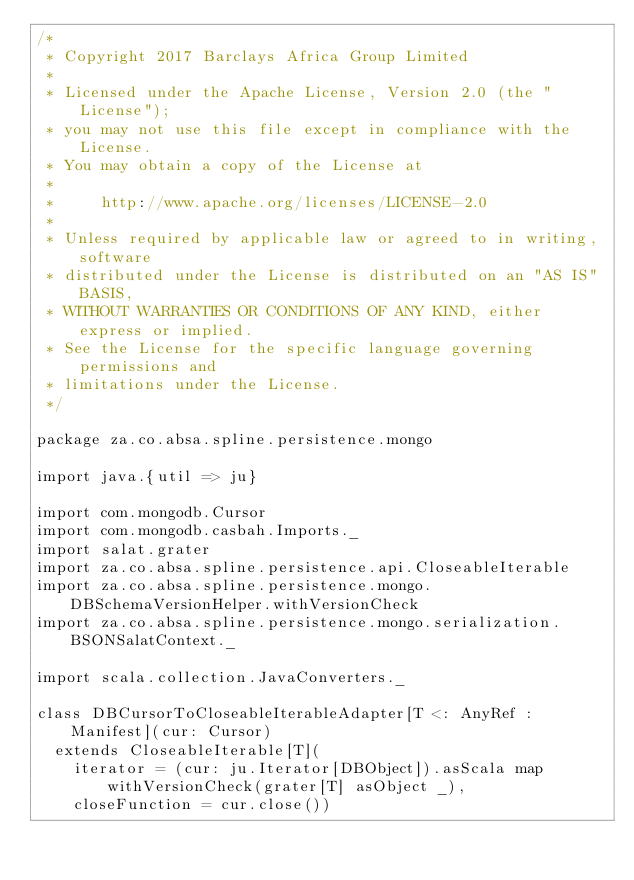<code> <loc_0><loc_0><loc_500><loc_500><_Scala_>/*
 * Copyright 2017 Barclays Africa Group Limited
 *
 * Licensed under the Apache License, Version 2.0 (the "License");
 * you may not use this file except in compliance with the License.
 * You may obtain a copy of the License at
 *
 *     http://www.apache.org/licenses/LICENSE-2.0
 *
 * Unless required by applicable law or agreed to in writing, software
 * distributed under the License is distributed on an "AS IS" BASIS,
 * WITHOUT WARRANTIES OR CONDITIONS OF ANY KIND, either express or implied.
 * See the License for the specific language governing permissions and
 * limitations under the License.
 */

package za.co.absa.spline.persistence.mongo

import java.{util => ju}

import com.mongodb.Cursor
import com.mongodb.casbah.Imports._
import salat.grater
import za.co.absa.spline.persistence.api.CloseableIterable
import za.co.absa.spline.persistence.mongo.DBSchemaVersionHelper.withVersionCheck
import za.co.absa.spline.persistence.mongo.serialization.BSONSalatContext._

import scala.collection.JavaConverters._

class DBCursorToCloseableIterableAdapter[T <: AnyRef : Manifest](cur: Cursor)
  extends CloseableIterable[T](
    iterator = (cur: ju.Iterator[DBObject]).asScala map withVersionCheck(grater[T] asObject _),
    closeFunction = cur.close())
</code> 